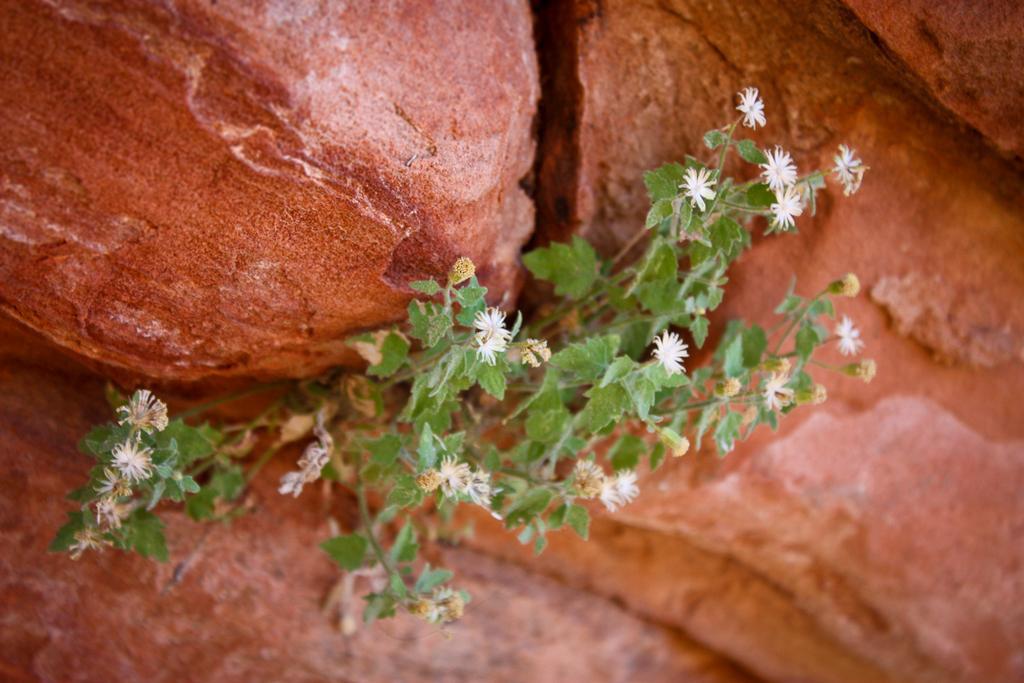Could you give a brief overview of what you see in this image? In this picture in the center there are flowers and plants and in the background there are rocks. 